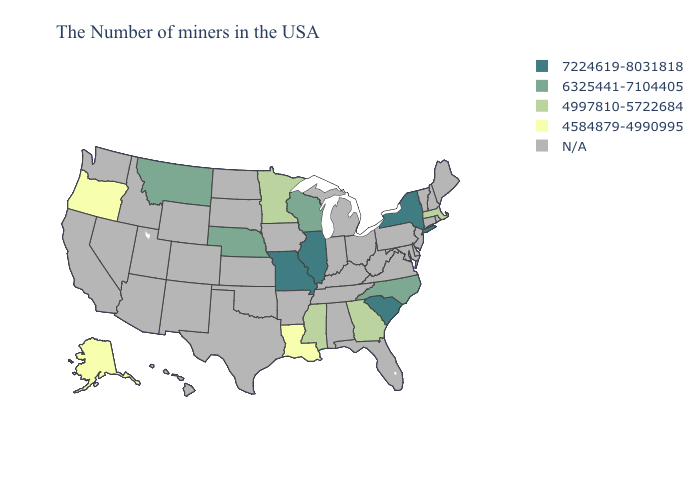What is the lowest value in the USA?
Short answer required. 4584879-4990995. Name the states that have a value in the range 4584879-4990995?
Be succinct. Louisiana, Oregon, Alaska. What is the lowest value in the South?
Keep it brief. 4584879-4990995. What is the highest value in the MidWest ?
Answer briefly. 7224619-8031818. Which states hav the highest value in the Northeast?
Answer briefly. New York. What is the lowest value in the USA?
Keep it brief. 4584879-4990995. Does the first symbol in the legend represent the smallest category?
Concise answer only. No. Which states have the lowest value in the Northeast?
Short answer required. Massachusetts. What is the lowest value in states that border Arkansas?
Answer briefly. 4584879-4990995. What is the value of Nevada?
Write a very short answer. N/A. What is the value of Texas?
Give a very brief answer. N/A. Name the states that have a value in the range 4997810-5722684?
Keep it brief. Massachusetts, Georgia, Mississippi, Minnesota. Name the states that have a value in the range N/A?
Give a very brief answer. Maine, Rhode Island, New Hampshire, Vermont, Connecticut, New Jersey, Delaware, Maryland, Pennsylvania, Virginia, West Virginia, Ohio, Florida, Michigan, Kentucky, Indiana, Alabama, Tennessee, Arkansas, Iowa, Kansas, Oklahoma, Texas, South Dakota, North Dakota, Wyoming, Colorado, New Mexico, Utah, Arizona, Idaho, Nevada, California, Washington, Hawaii. Does Montana have the lowest value in the West?
Answer briefly. No. 